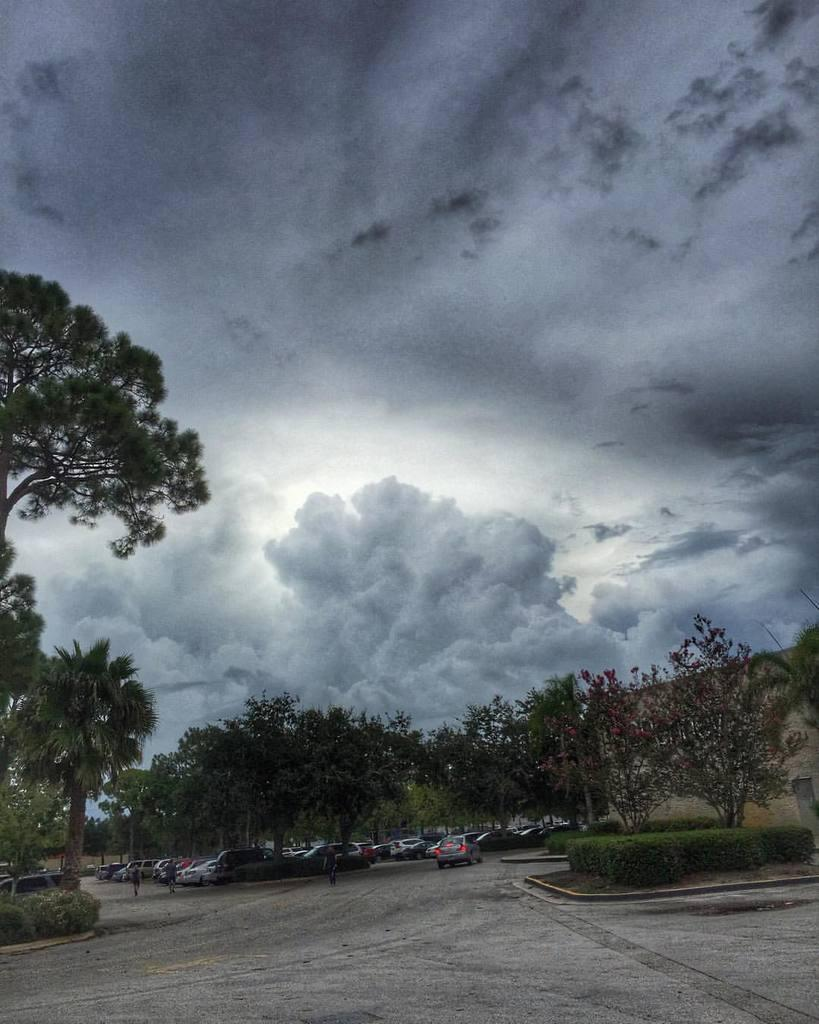What is located in the foreground of the image? There are plants, trees, and fleets of vehicles in the foreground of the image. What type of environment is depicted in the image? The image appears to be taken on a road. What can be seen in the background of the image? The sky is visible in the background of the image. What type of advertisement can be seen on the edge of the road in the image? There is no advertisement present on the edge of the road in the image. Are there any feathers visible in the image? There are no feathers present in the image. 